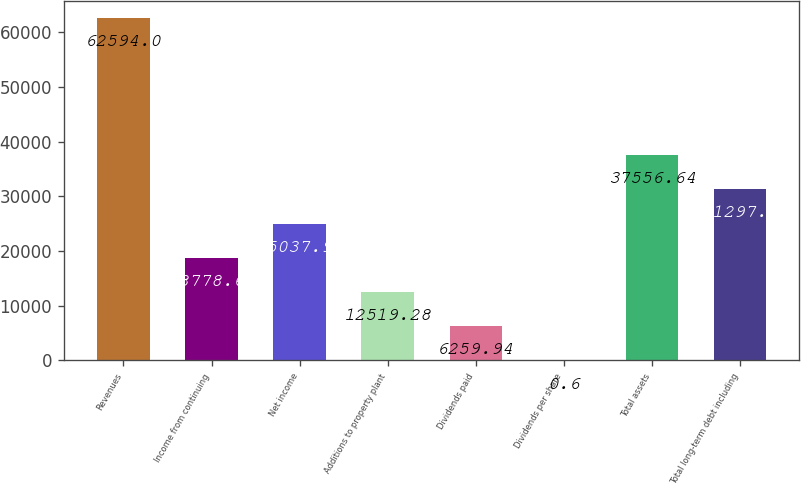Convert chart to OTSL. <chart><loc_0><loc_0><loc_500><loc_500><bar_chart><fcel>Revenues<fcel>Income from continuing<fcel>Net income<fcel>Additions to property plant<fcel>Dividends paid<fcel>Dividends per share<fcel>Total assets<fcel>Total long-term debt including<nl><fcel>62594<fcel>18778.6<fcel>25038<fcel>12519.3<fcel>6259.94<fcel>0.6<fcel>37556.6<fcel>31297.3<nl></chart> 